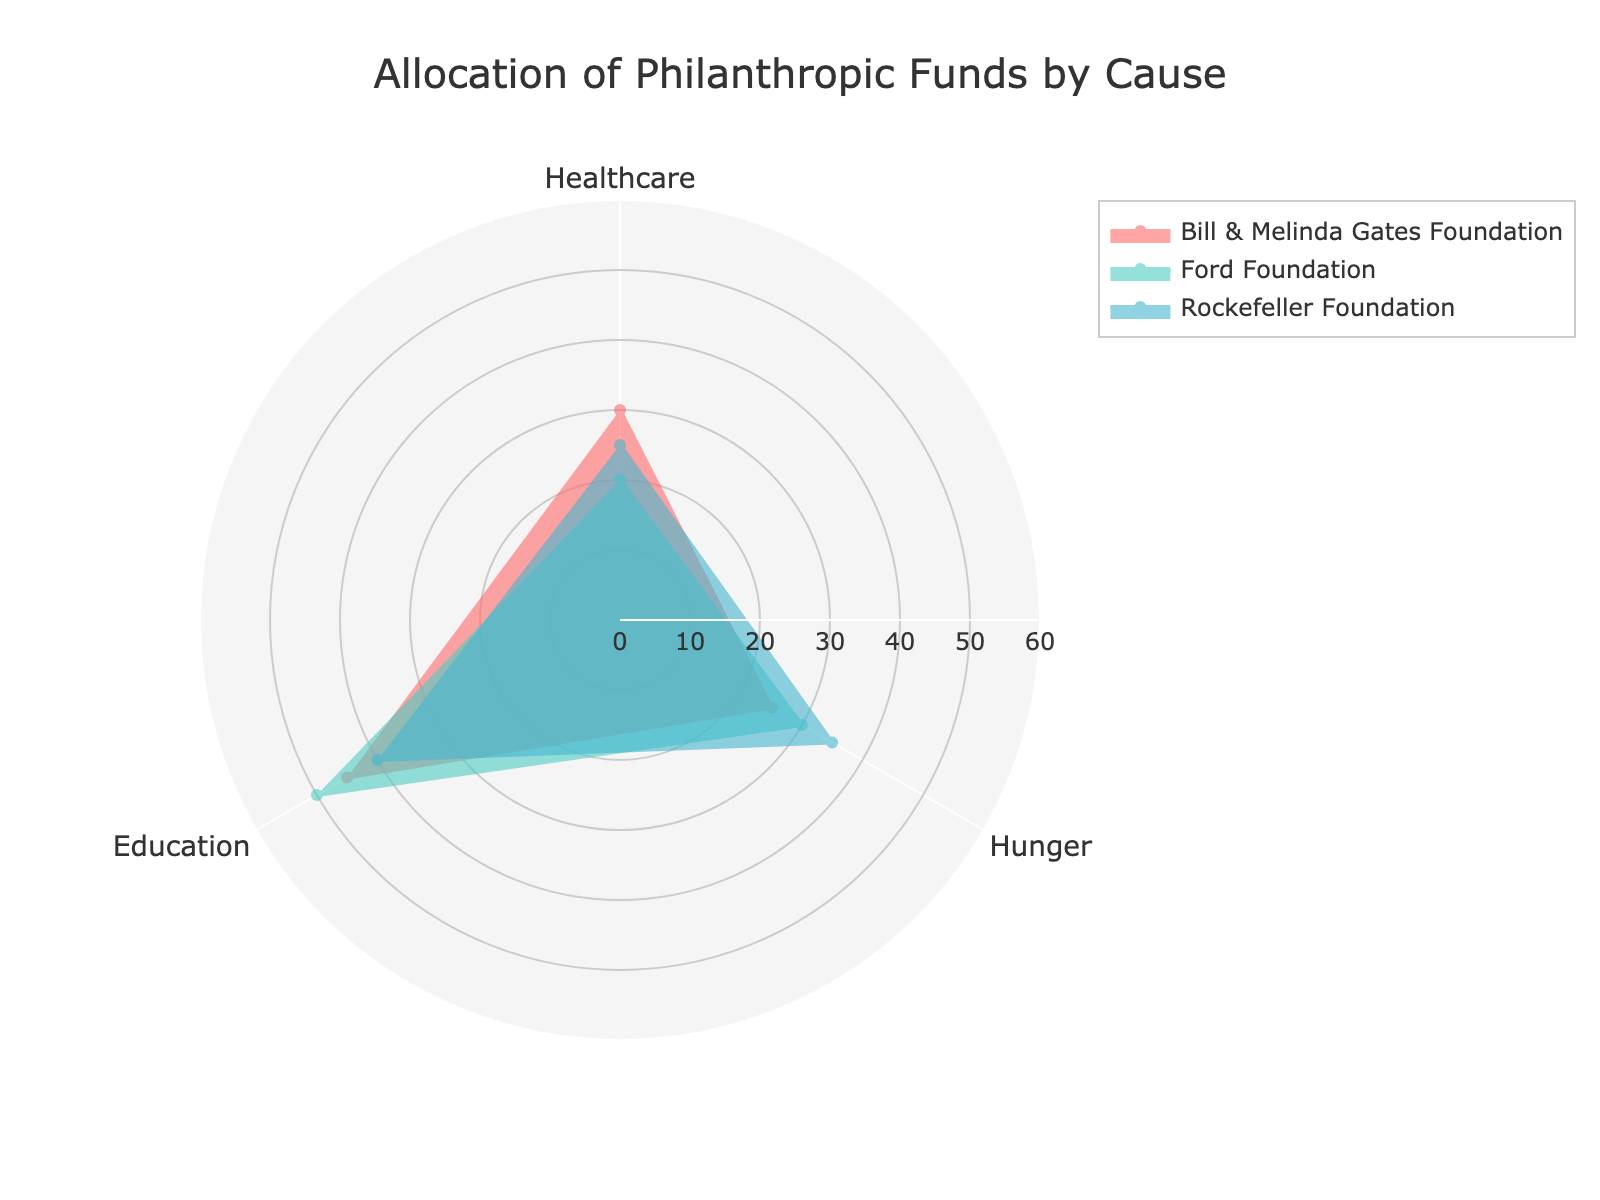What is the title of the radar chart? The title of the radar chart is usually displayed at the top of the chart. By reading this text, we can identify the title as "Allocation of Philanthropic Funds by Cause".
Answer: Allocation of Philanthropic Funds by Cause Which cause receives the most funds from the Bill & Melinda Gates Foundation? In the radar chart, locate the segment corresponding to the Bill & Melinda Gates Foundation. Then, check the values for each cause (Healthcare, Hunger, Education). The highest value is 45 for Education.
Answer: Education What is the range of the radial axis in the radar chart? The radial axis range is typically indicated in the chart settings, often prominently visible along the chart's radial lines. It ranges from 0 to 60, as mentioned in the chart description.
Answer: 0 to 60 Which foundation allocates the least amount of funds to Hunger? Examine the segments for all three foundations and compare the values allocated to Hunger. The lowest allocation to Hunger (25) is from the Bill & Melinda Gates Foundation.
Answer: Bill & Melinda Gates Foundation What is the average amount of funds allocated to Education by all foundations? To find the average, add the allocations for Education from all foundations (45 + 50 + 40 = 135) and divide by the number of foundations (3). The average is 135 / 3 = 45.
Answer: 45 Which foundation has the most balanced allocation across all causes? To determine which foundation has the most balanced allocation, look for one where the values are closest to each other for all causes. The Ford Foundation allocates 20, 30, and 50, which are closer in range compared to the other foundations.
Answer: Ford Foundation How much more does the Rockefeller Foundation allocate to Hunger compared to Healthcare? Subtract the amount allocated to Healthcare from the amount allocated to Hunger for the Rockefeller Foundation (35 - 25). The difference is 10.
Answer: 10 Which cause has the highest allocation across all foundations? To find the highest overall allocation, examine all the individual values for each cause and identify the maximum. Education (50 from Ford Foundation) has the highest allocation.
Answer: Education Which foundation allocates the least amount of funds overall? To determine the foundation with the least allocation, sum up the allocations for each foundation and compare: Bill & Melinda Gates Foundation (30+25+45=100), Ford Foundation (20+30+50=100), Rockefeller Foundation (25+35+40=100). All have the same total allocation of 100, so the answer involves understanding none allocates fewer.
Answer: None, all allocate equally 